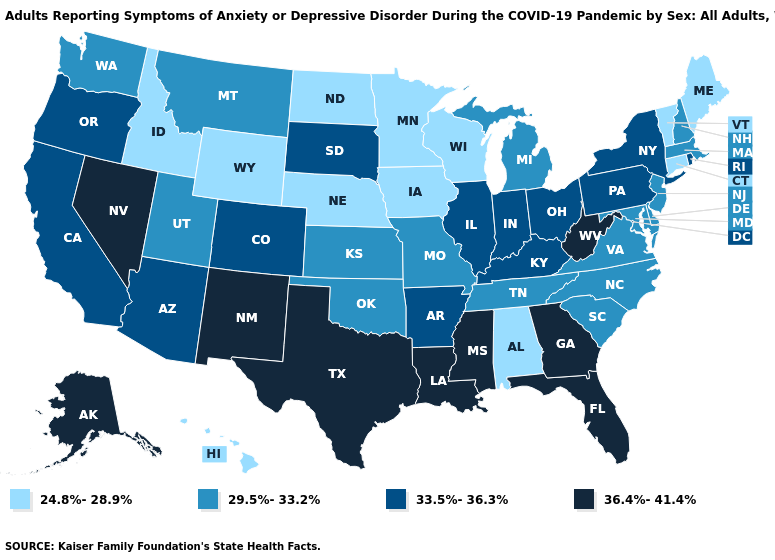Does New Mexico have the highest value in the West?
Concise answer only. Yes. What is the highest value in the USA?
Quick response, please. 36.4%-41.4%. Name the states that have a value in the range 29.5%-33.2%?
Be succinct. Delaware, Kansas, Maryland, Massachusetts, Michigan, Missouri, Montana, New Hampshire, New Jersey, North Carolina, Oklahoma, South Carolina, Tennessee, Utah, Virginia, Washington. Does the map have missing data?
Be succinct. No. What is the highest value in states that border West Virginia?
Give a very brief answer. 33.5%-36.3%. What is the lowest value in the West?
Keep it brief. 24.8%-28.9%. Does Connecticut have the lowest value in the Northeast?
Keep it brief. Yes. What is the value of North Dakota?
Quick response, please. 24.8%-28.9%. Name the states that have a value in the range 29.5%-33.2%?
Write a very short answer. Delaware, Kansas, Maryland, Massachusetts, Michigan, Missouri, Montana, New Hampshire, New Jersey, North Carolina, Oklahoma, South Carolina, Tennessee, Utah, Virginia, Washington. Does the first symbol in the legend represent the smallest category?
Keep it brief. Yes. Name the states that have a value in the range 33.5%-36.3%?
Give a very brief answer. Arizona, Arkansas, California, Colorado, Illinois, Indiana, Kentucky, New York, Ohio, Oregon, Pennsylvania, Rhode Island, South Dakota. How many symbols are there in the legend?
Give a very brief answer. 4. What is the value of Indiana?
Keep it brief. 33.5%-36.3%. Which states have the lowest value in the USA?
Concise answer only. Alabama, Connecticut, Hawaii, Idaho, Iowa, Maine, Minnesota, Nebraska, North Dakota, Vermont, Wisconsin, Wyoming. 